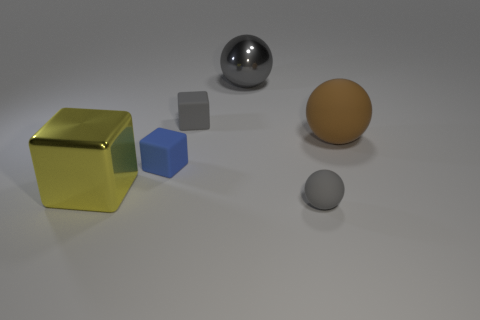Subtract all metal cubes. How many cubes are left? 2 Add 2 large red cylinders. How many objects exist? 8 Subtract 1 balls. How many balls are left? 2 Subtract all blue blocks. How many blocks are left? 2 Subtract 0 brown cylinders. How many objects are left? 6 Subtract all green cubes. Subtract all yellow cylinders. How many cubes are left? 3 Subtract all brown spheres. How many blue blocks are left? 1 Subtract all large shiny spheres. Subtract all large yellow metallic cubes. How many objects are left? 4 Add 5 blue objects. How many blue objects are left? 6 Add 6 small purple rubber balls. How many small purple rubber balls exist? 6 